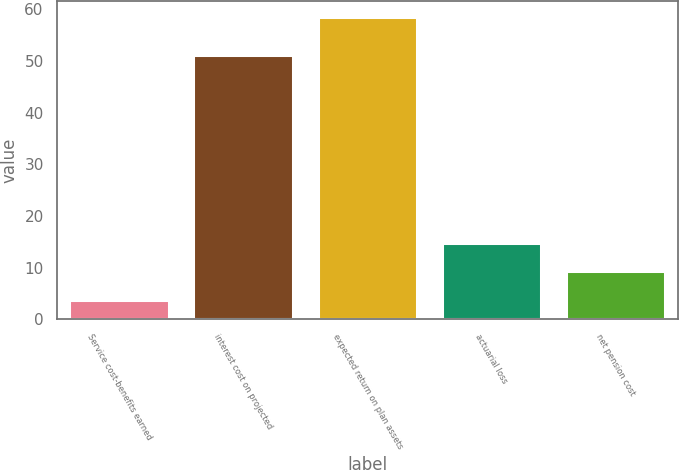Convert chart. <chart><loc_0><loc_0><loc_500><loc_500><bar_chart><fcel>Service cost-benefits earned<fcel>interest cost on projected<fcel>expected return on plan assets<fcel>actuarial loss<fcel>net pension cost<nl><fcel>3.8<fcel>51.2<fcel>58.6<fcel>14.76<fcel>9.28<nl></chart> 